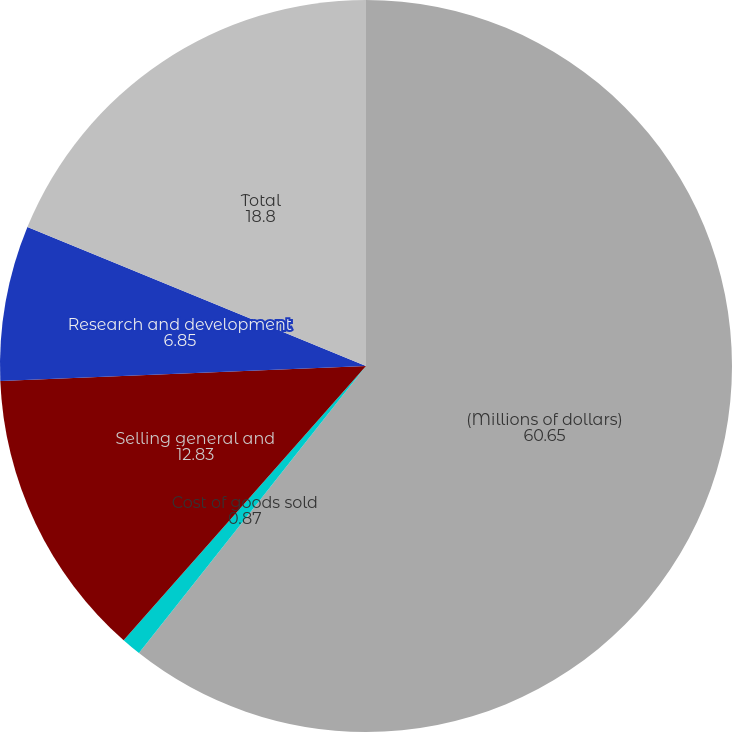Convert chart. <chart><loc_0><loc_0><loc_500><loc_500><pie_chart><fcel>(Millions of dollars)<fcel>Cost of goods sold<fcel>Selling general and<fcel>Research and development<fcel>Total<nl><fcel>60.65%<fcel>0.87%<fcel>12.83%<fcel>6.85%<fcel>18.8%<nl></chart> 